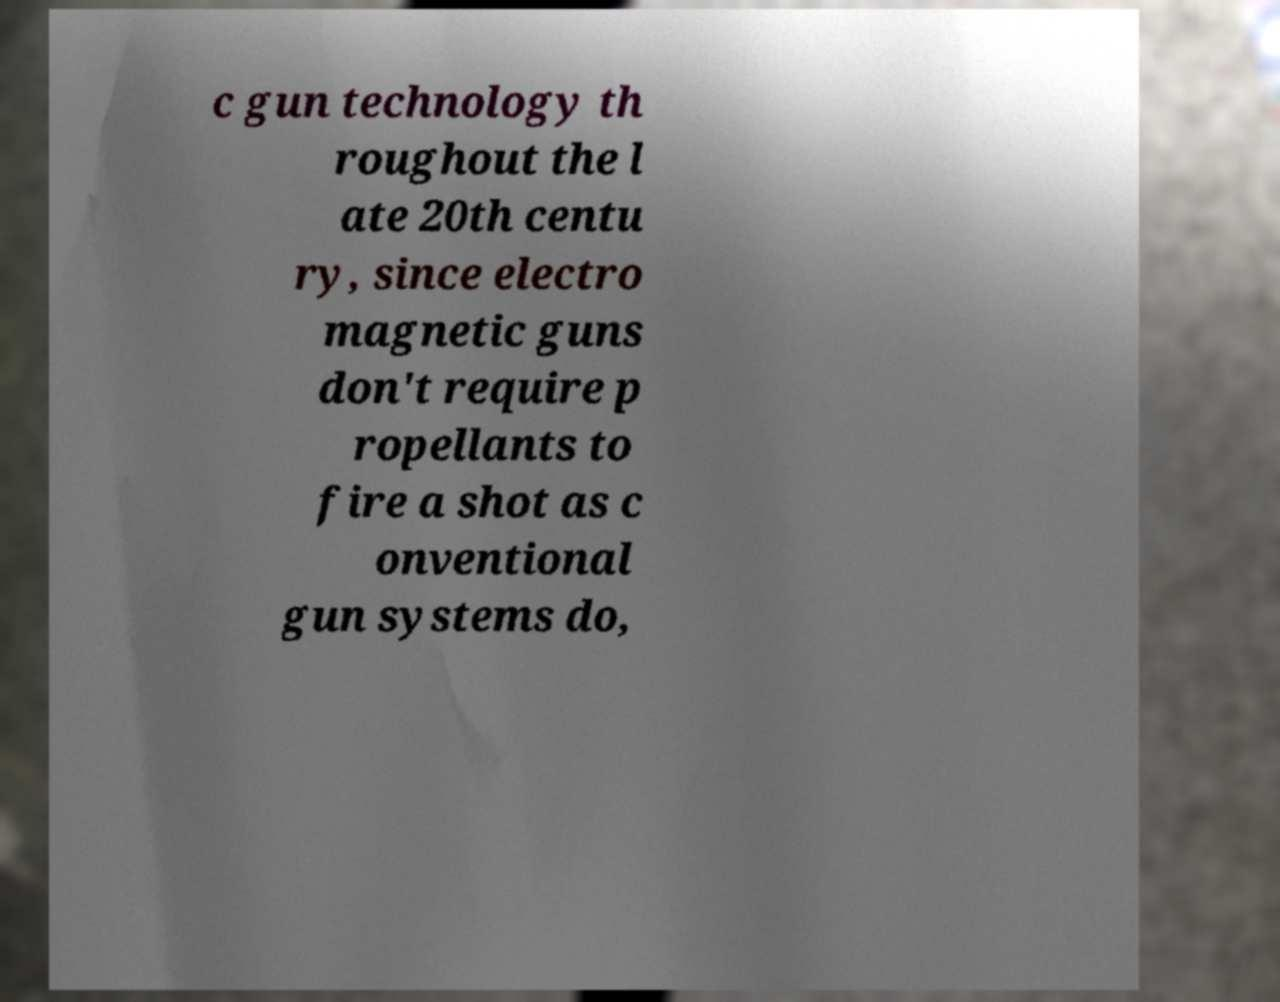There's text embedded in this image that I need extracted. Can you transcribe it verbatim? c gun technology th roughout the l ate 20th centu ry, since electro magnetic guns don't require p ropellants to fire a shot as c onventional gun systems do, 